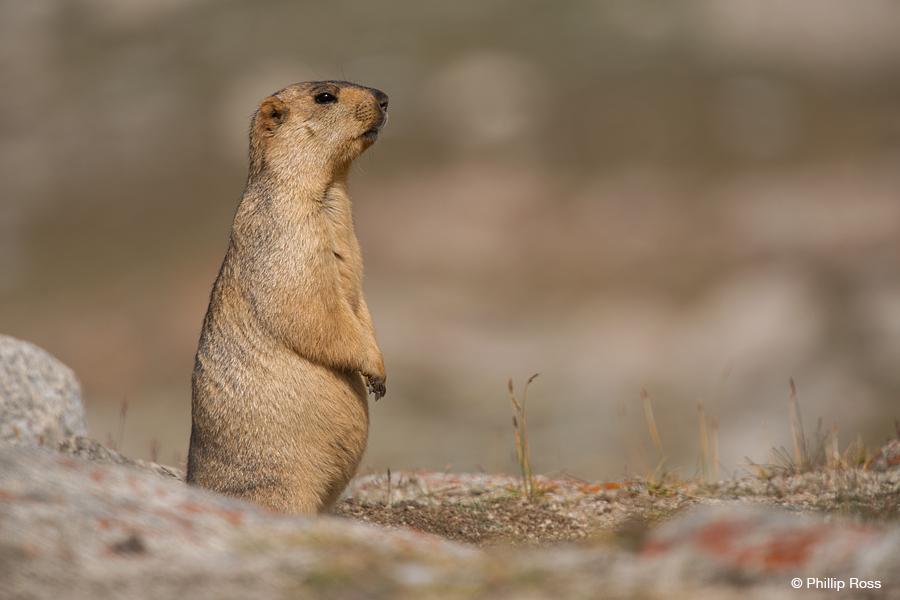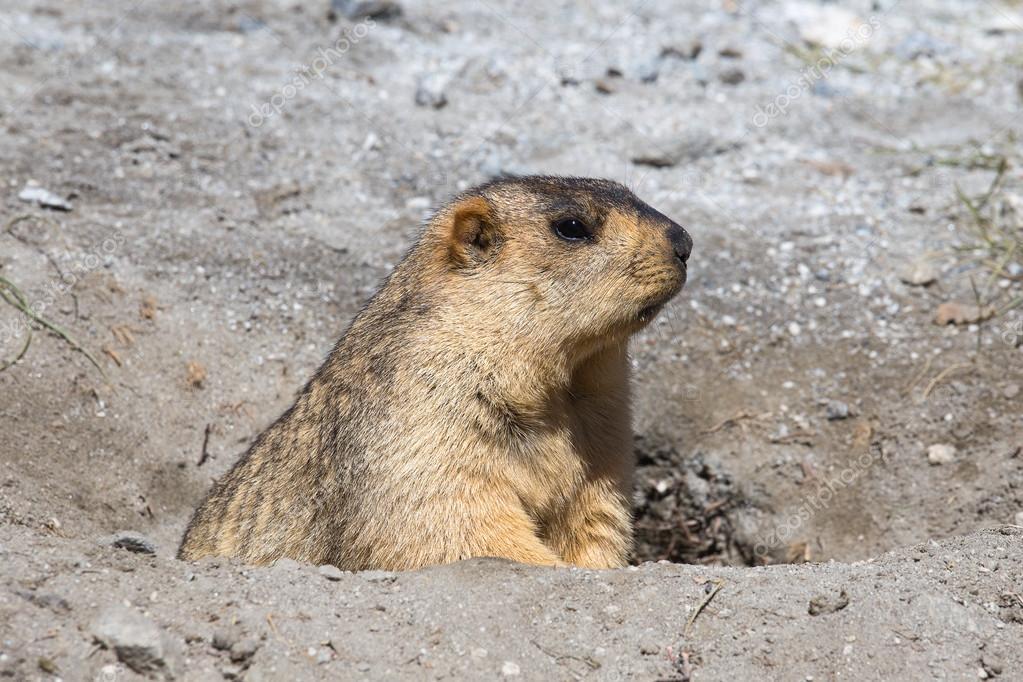The first image is the image on the left, the second image is the image on the right. Given the left and right images, does the statement "a single gopher is standing on hind legs with it's arms down" hold true? Answer yes or no. Yes. 